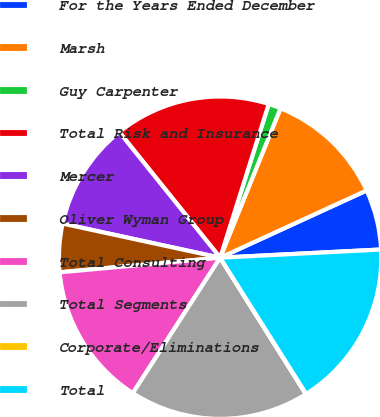Convert chart to OTSL. <chart><loc_0><loc_0><loc_500><loc_500><pie_chart><fcel>For the Years Ended December<fcel>Marsh<fcel>Guy Carpenter<fcel>Total Risk and Insurance<fcel>Mercer<fcel>Oliver Wyman Group<fcel>Total Consulting<fcel>Total Segments<fcel>Corporate/Eliminations<fcel>Total<nl><fcel>6.04%<fcel>12.04%<fcel>1.24%<fcel>15.64%<fcel>10.84%<fcel>4.84%<fcel>14.44%<fcel>18.04%<fcel>0.04%<fcel>16.84%<nl></chart> 